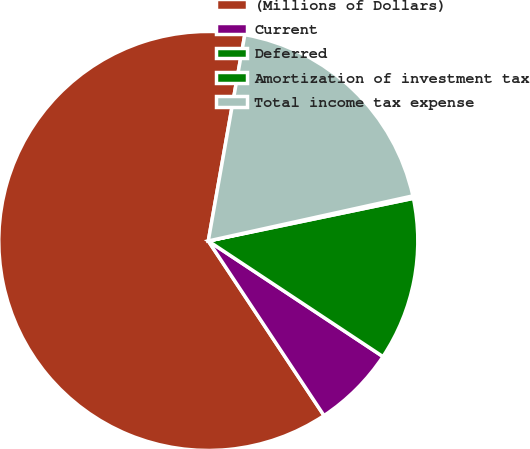Convert chart to OTSL. <chart><loc_0><loc_0><loc_500><loc_500><pie_chart><fcel>(Millions of Dollars)<fcel>Current<fcel>Deferred<fcel>Amortization of investment tax<fcel>Total income tax expense<nl><fcel>62.11%<fcel>6.38%<fcel>12.57%<fcel>0.19%<fcel>18.76%<nl></chart> 